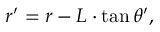Convert formula to latex. <formula><loc_0><loc_0><loc_500><loc_500>r ^ { \prime } = r - L \cdot \tan \theta ^ { \prime } ,</formula> 